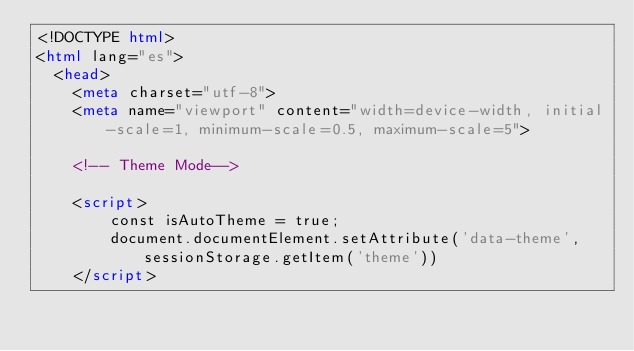<code> <loc_0><loc_0><loc_500><loc_500><_HTML_><!DOCTYPE html>
<html lang="es">
  <head>
    <meta charset="utf-8">
    <meta name="viewport" content="width=device-width, initial-scale=1, minimum-scale=0.5, maximum-scale=5">

    <!-- Theme Mode-->
    
    <script>
        const isAutoTheme = true;
        document.documentElement.setAttribute('data-theme', sessionStorage.getItem('theme'))
    </script>
    
</code> 